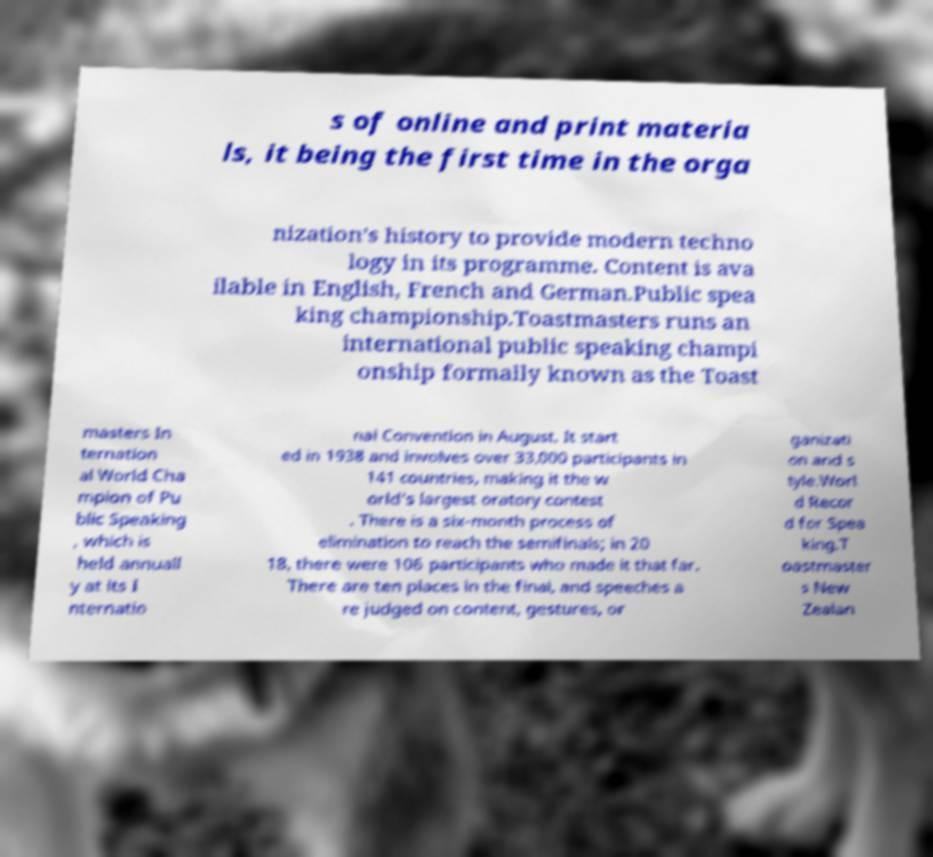For documentation purposes, I need the text within this image transcribed. Could you provide that? s of online and print materia ls, it being the first time in the orga nization’s history to provide modern techno logy in its programme. Content is ava ilable in English, French and German.Public spea king championship.Toastmasters runs an international public speaking champi onship formally known as the Toast masters In ternation al World Cha mpion of Pu blic Speaking , which is held annuall y at its I nternatio nal Convention in August. It start ed in 1938 and involves over 33,000 participants in 141 countries, making it the w orld's largest oratory contest . There is a six-month process of elimination to reach the semifinals; in 20 18, there were 106 participants who made it that far. There are ten places in the final, and speeches a re judged on content, gestures, or ganizati on and s tyle.Worl d Recor d for Spea king.T oastmaster s New Zealan 